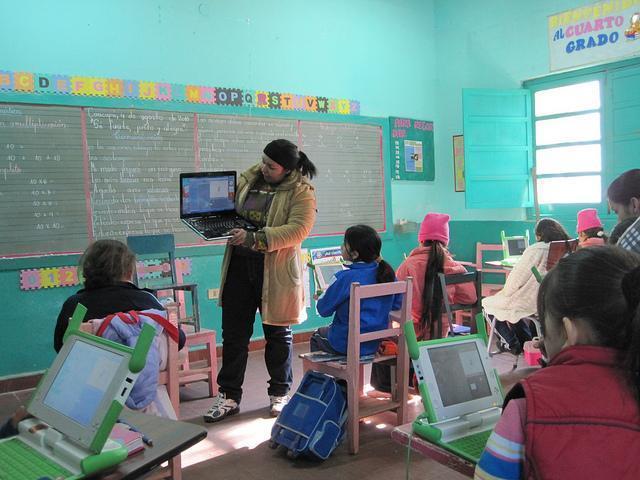How many people are there?
Give a very brief answer. 6. How many laptops are there?
Give a very brief answer. 3. How many chairs can you see?
Give a very brief answer. 3. How many backpacks can you see?
Give a very brief answer. 2. How many cars are in the picture before the overhead signs?
Give a very brief answer. 0. 